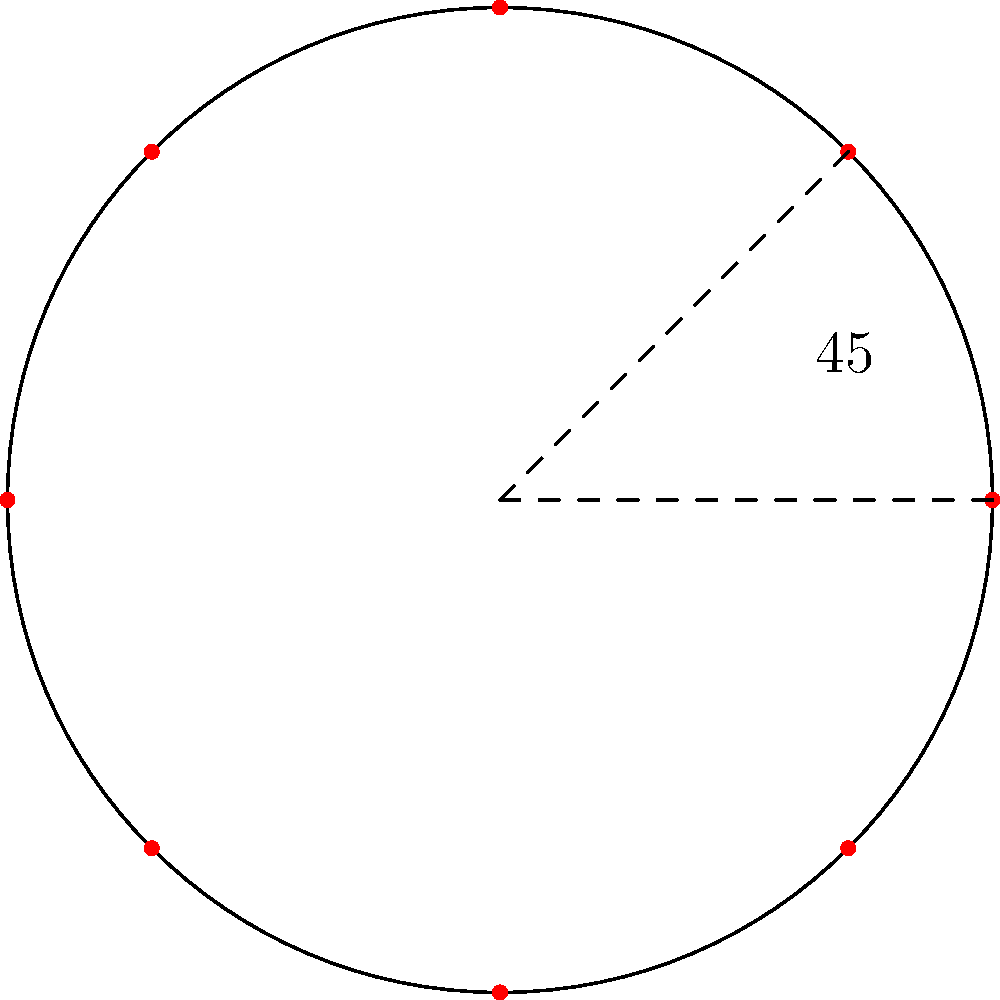For a 360-degree stop-motion animation shot, you need to arrange 8 cameras in a circular formation. If the cameras are placed at equal intervals around the circle, what is the angle (in degrees) between each adjacent camera? To solve this problem, we need to follow these steps:

1. Understand that a full circle contains 360°.
2. Recognize that we need to divide the circle equally among 8 cameras.
3. Calculate the angle between adjacent cameras:

   $$\text{Angle} = \frac{\text{Total degrees in a circle}}{\text{Number of cameras}}$$
   
   $$\text{Angle} = \frac{360°}{8}$$
   
   $$\text{Angle} = 45°$$

4. Verify: If we multiply 45° by 8, we get 360°, confirming that this arrangement covers the entire circle.

The diagram shows a circle with 8 equally spaced points (representing the cameras) and highlights the 45° angle between two adjacent points.
Answer: 45° 